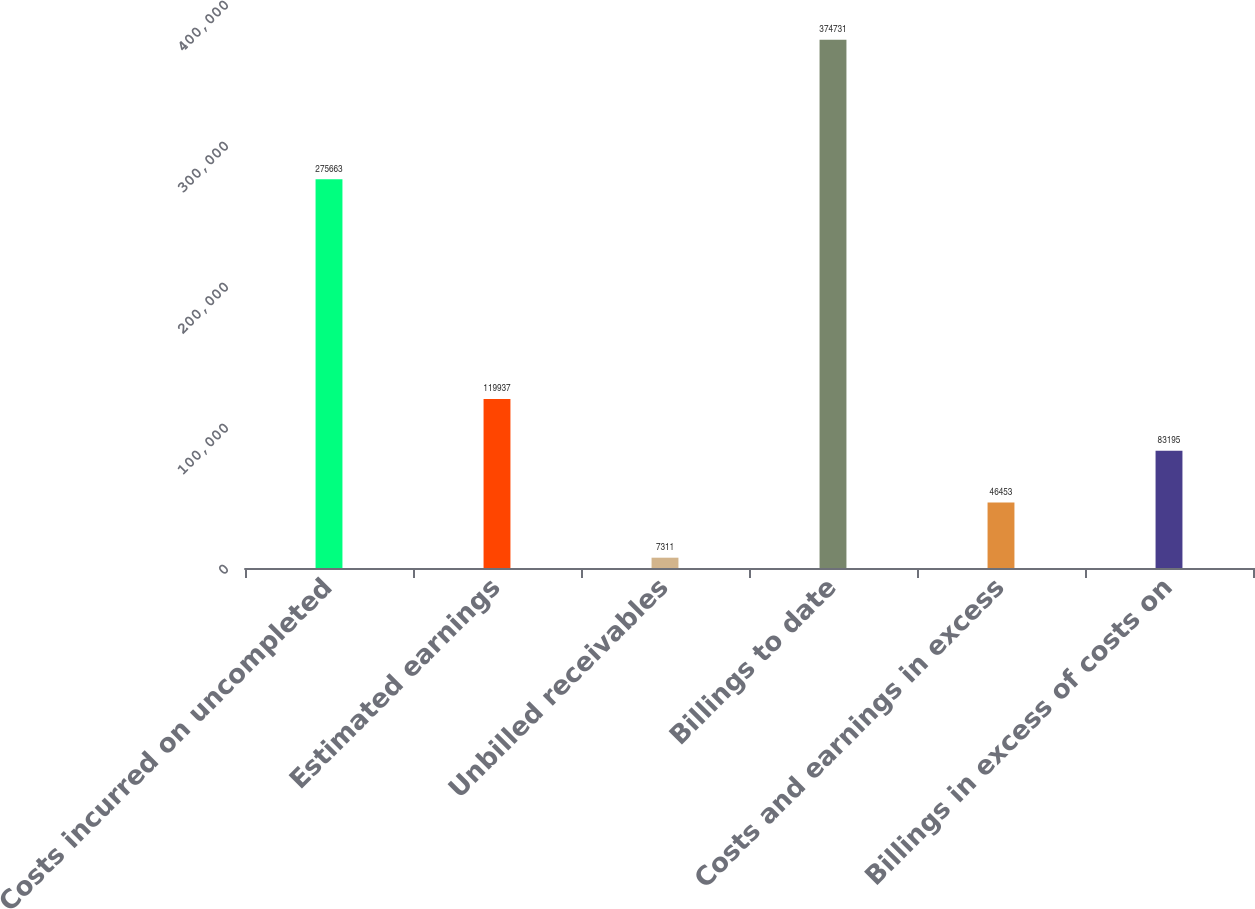Convert chart to OTSL. <chart><loc_0><loc_0><loc_500><loc_500><bar_chart><fcel>Costs incurred on uncompleted<fcel>Estimated earnings<fcel>Unbilled receivables<fcel>Billings to date<fcel>Costs and earnings in excess<fcel>Billings in excess of costs on<nl><fcel>275663<fcel>119937<fcel>7311<fcel>374731<fcel>46453<fcel>83195<nl></chart> 